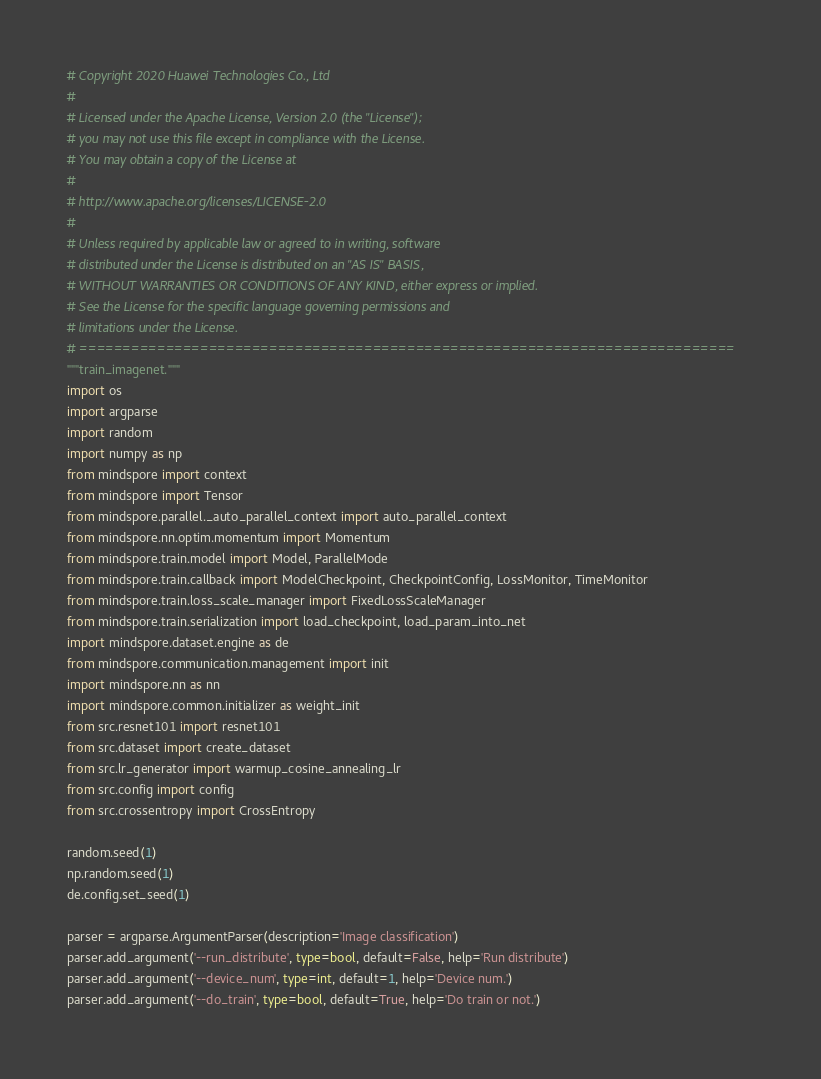Convert code to text. <code><loc_0><loc_0><loc_500><loc_500><_Python_># Copyright 2020 Huawei Technologies Co., Ltd
#
# Licensed under the Apache License, Version 2.0 (the "License");
# you may not use this file except in compliance with the License.
# You may obtain a copy of the License at
#
# http://www.apache.org/licenses/LICENSE-2.0
#
# Unless required by applicable law or agreed to in writing, software
# distributed under the License is distributed on an "AS IS" BASIS,
# WITHOUT WARRANTIES OR CONDITIONS OF ANY KIND, either express or implied.
# See the License for the specific language governing permissions and
# limitations under the License.
# ============================================================================
"""train_imagenet."""
import os
import argparse
import random
import numpy as np
from mindspore import context
from mindspore import Tensor
from mindspore.parallel._auto_parallel_context import auto_parallel_context
from mindspore.nn.optim.momentum import Momentum
from mindspore.train.model import Model, ParallelMode
from mindspore.train.callback import ModelCheckpoint, CheckpointConfig, LossMonitor, TimeMonitor
from mindspore.train.loss_scale_manager import FixedLossScaleManager
from mindspore.train.serialization import load_checkpoint, load_param_into_net
import mindspore.dataset.engine as de
from mindspore.communication.management import init
import mindspore.nn as nn
import mindspore.common.initializer as weight_init
from src.resnet101 import resnet101
from src.dataset import create_dataset
from src.lr_generator import warmup_cosine_annealing_lr
from src.config import config
from src.crossentropy import CrossEntropy

random.seed(1)
np.random.seed(1)
de.config.set_seed(1)

parser = argparse.ArgumentParser(description='Image classification')
parser.add_argument('--run_distribute', type=bool, default=False, help='Run distribute')
parser.add_argument('--device_num', type=int, default=1, help='Device num.')
parser.add_argument('--do_train', type=bool, default=True, help='Do train or not.')</code> 